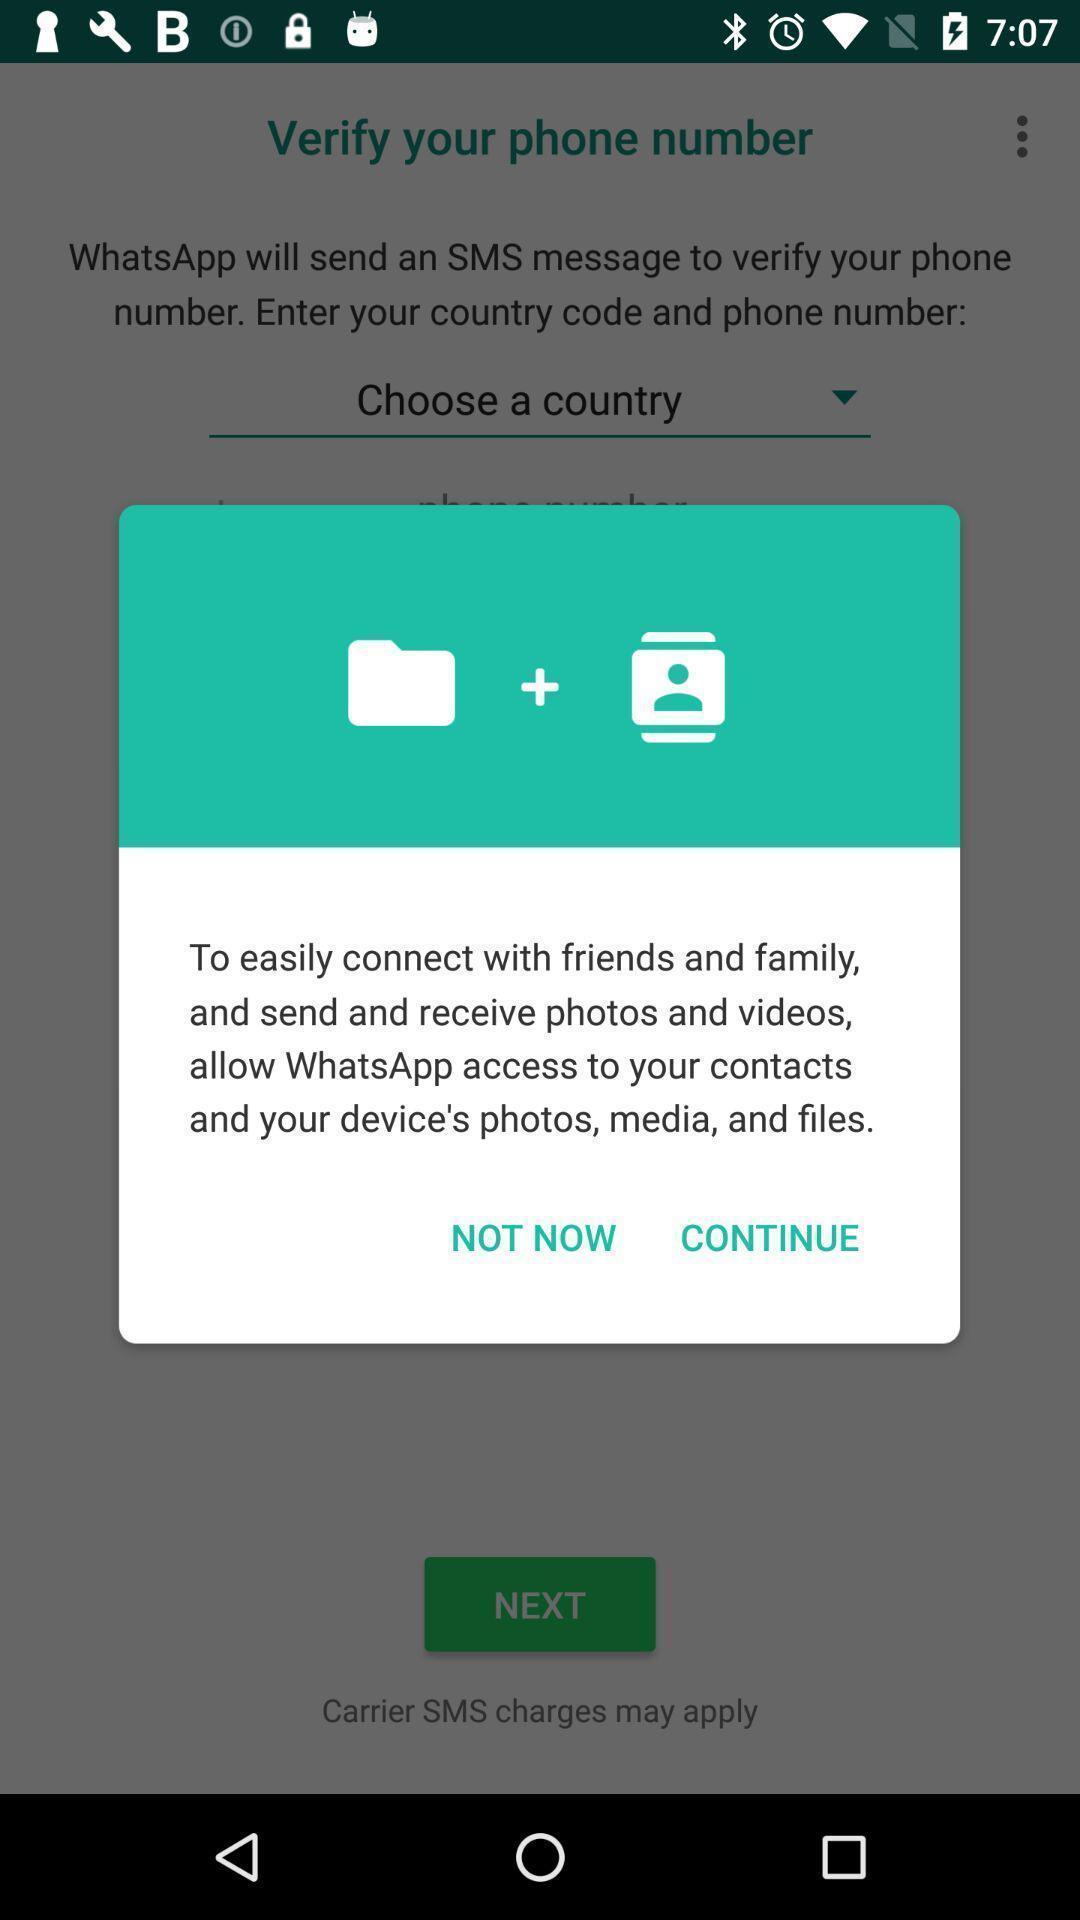What details can you identify in this image? Pop-up displaying options to connect with friends. 